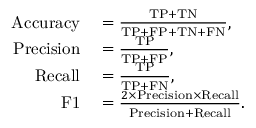<formula> <loc_0><loc_0><loc_500><loc_500>\begin{array} { r l } { A c c u r a c y } & = \frac { T P + T N } { T P + F P + T N + F N } , } \\ { P r e c i s i o n } & = \frac { T P } { T P + F P } , } \\ { R e c a l l } & = \frac { T P } { T P + F N } , } \\ { F 1 } & = \frac { 2 \times P r e c i s i o n \times R e c a l l } { P r e c i s i o n + R e c a l l } . } \end{array}</formula> 